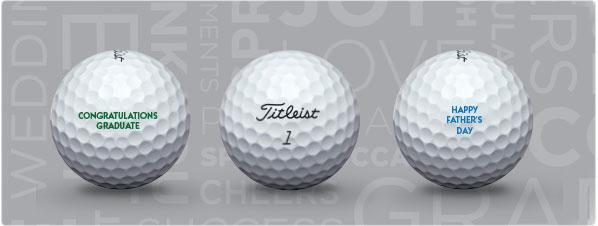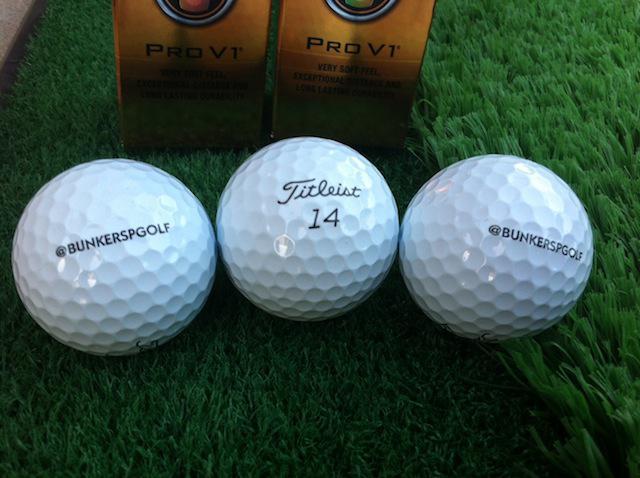The first image is the image on the left, the second image is the image on the right. Examine the images to the left and right. Is the description "The left and right image contains a total of six golf balls." accurate? Answer yes or no. Yes. The first image is the image on the left, the second image is the image on the right. Given the left and right images, does the statement "The combined images contain exactly six white golf balls." hold true? Answer yes or no. Yes. 